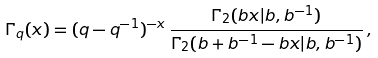Convert formula to latex. <formula><loc_0><loc_0><loc_500><loc_500>\Gamma _ { q } ( x ) = ( q - q ^ { - 1 } ) ^ { - x } \, \frac { \Gamma _ { 2 } ( b x | b , b ^ { - 1 } ) } { \Gamma _ { 2 } ( b + b ^ { - 1 } - b x | b , b ^ { - 1 } ) } \, ,</formula> 